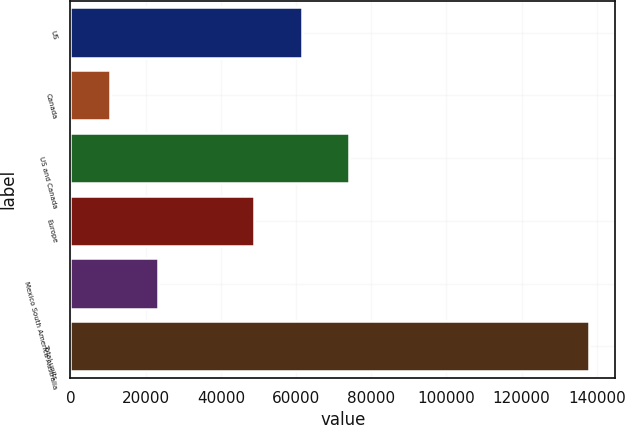<chart> <loc_0><loc_0><loc_500><loc_500><bar_chart><fcel>US<fcel>Canada<fcel>US and Canada<fcel>Europe<fcel>Mexico South America Australia<fcel>Total units<nl><fcel>61450<fcel>10500<fcel>74200<fcel>48700<fcel>23250<fcel>138000<nl></chart> 